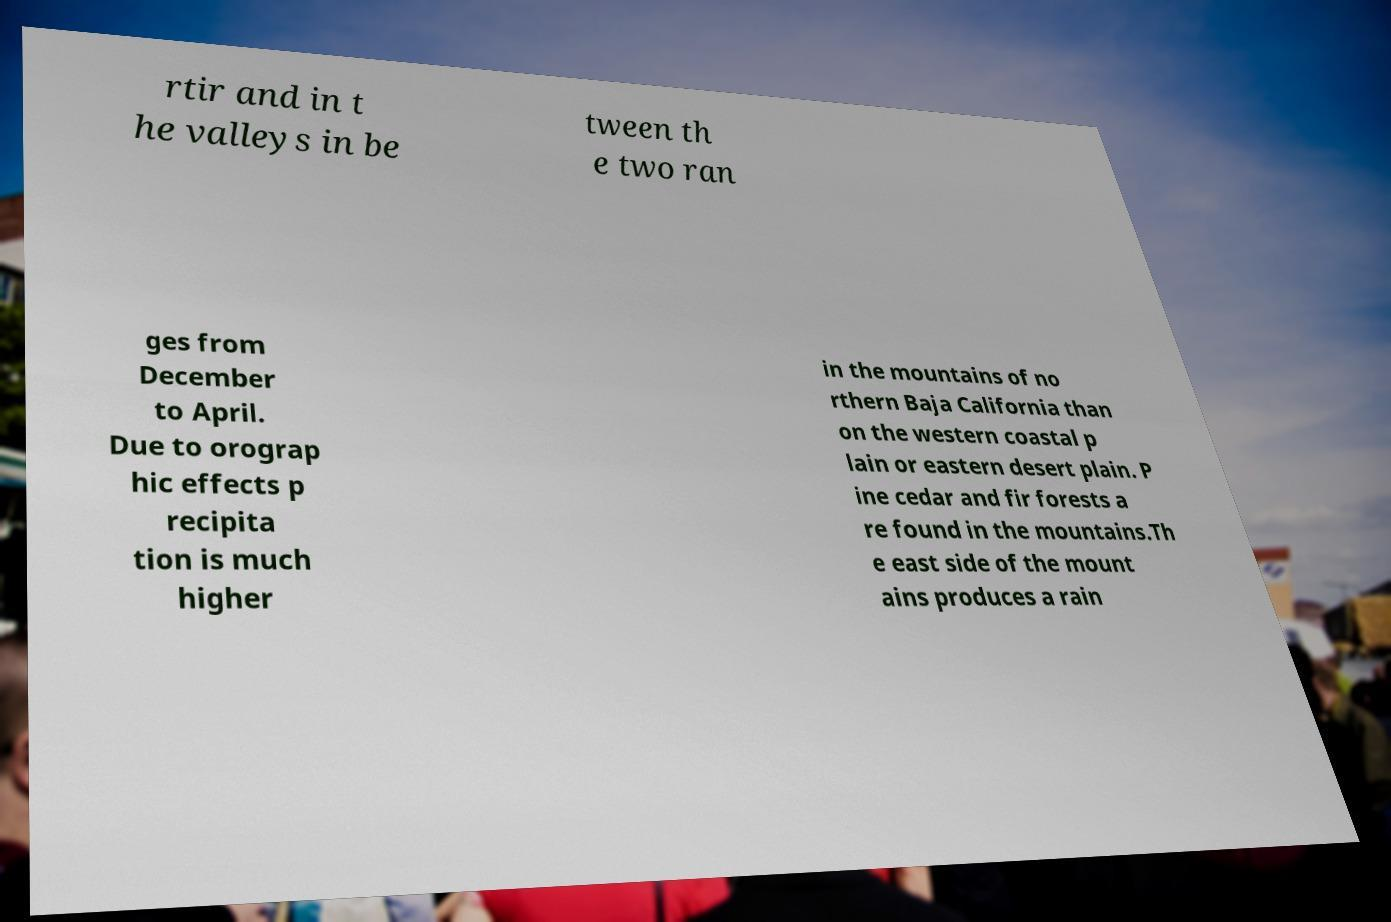I need the written content from this picture converted into text. Can you do that? rtir and in t he valleys in be tween th e two ran ges from December to April. Due to orograp hic effects p recipita tion is much higher in the mountains of no rthern Baja California than on the western coastal p lain or eastern desert plain. P ine cedar and fir forests a re found in the mountains.Th e east side of the mount ains produces a rain 